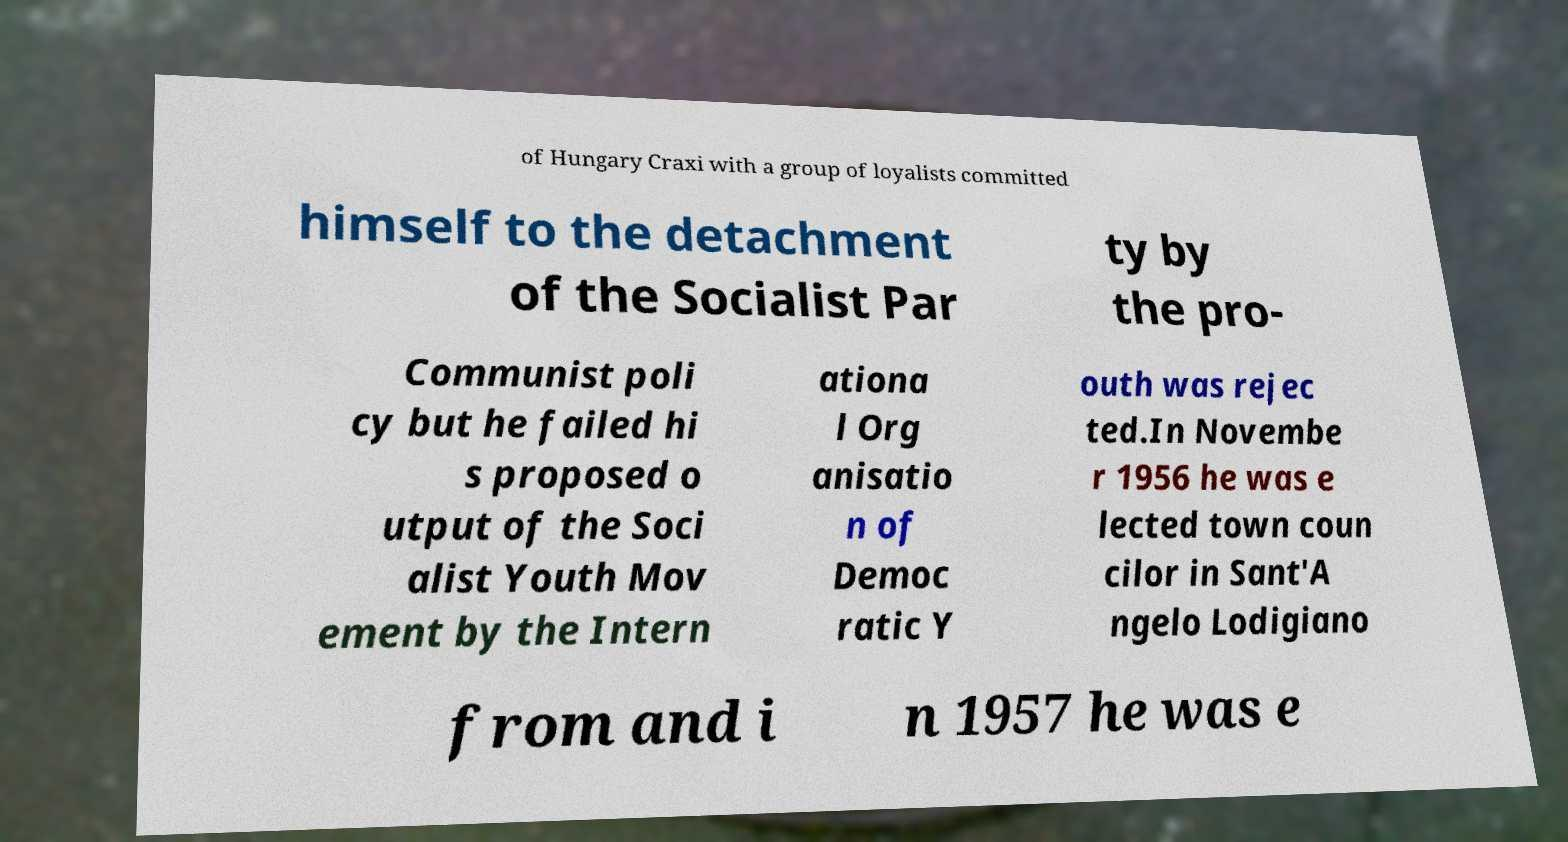Can you read and provide the text displayed in the image?This photo seems to have some interesting text. Can you extract and type it out for me? of Hungary Craxi with a group of loyalists committed himself to the detachment of the Socialist Par ty by the pro- Communist poli cy but he failed hi s proposed o utput of the Soci alist Youth Mov ement by the Intern ationa l Org anisatio n of Democ ratic Y outh was rejec ted.In Novembe r 1956 he was e lected town coun cilor in Sant'A ngelo Lodigiano from and i n 1957 he was e 